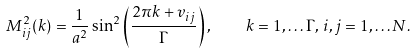Convert formula to latex. <formula><loc_0><loc_0><loc_500><loc_500>M _ { i j } ^ { 2 } ( k ) = \frac { 1 } { a ^ { 2 } } \sin ^ { 2 } \left ( \frac { 2 \pi k + v _ { i j } } { \Gamma } \right ) , \quad k = 1 , \dots \Gamma , \, i , j = 1 , \dots N .</formula> 